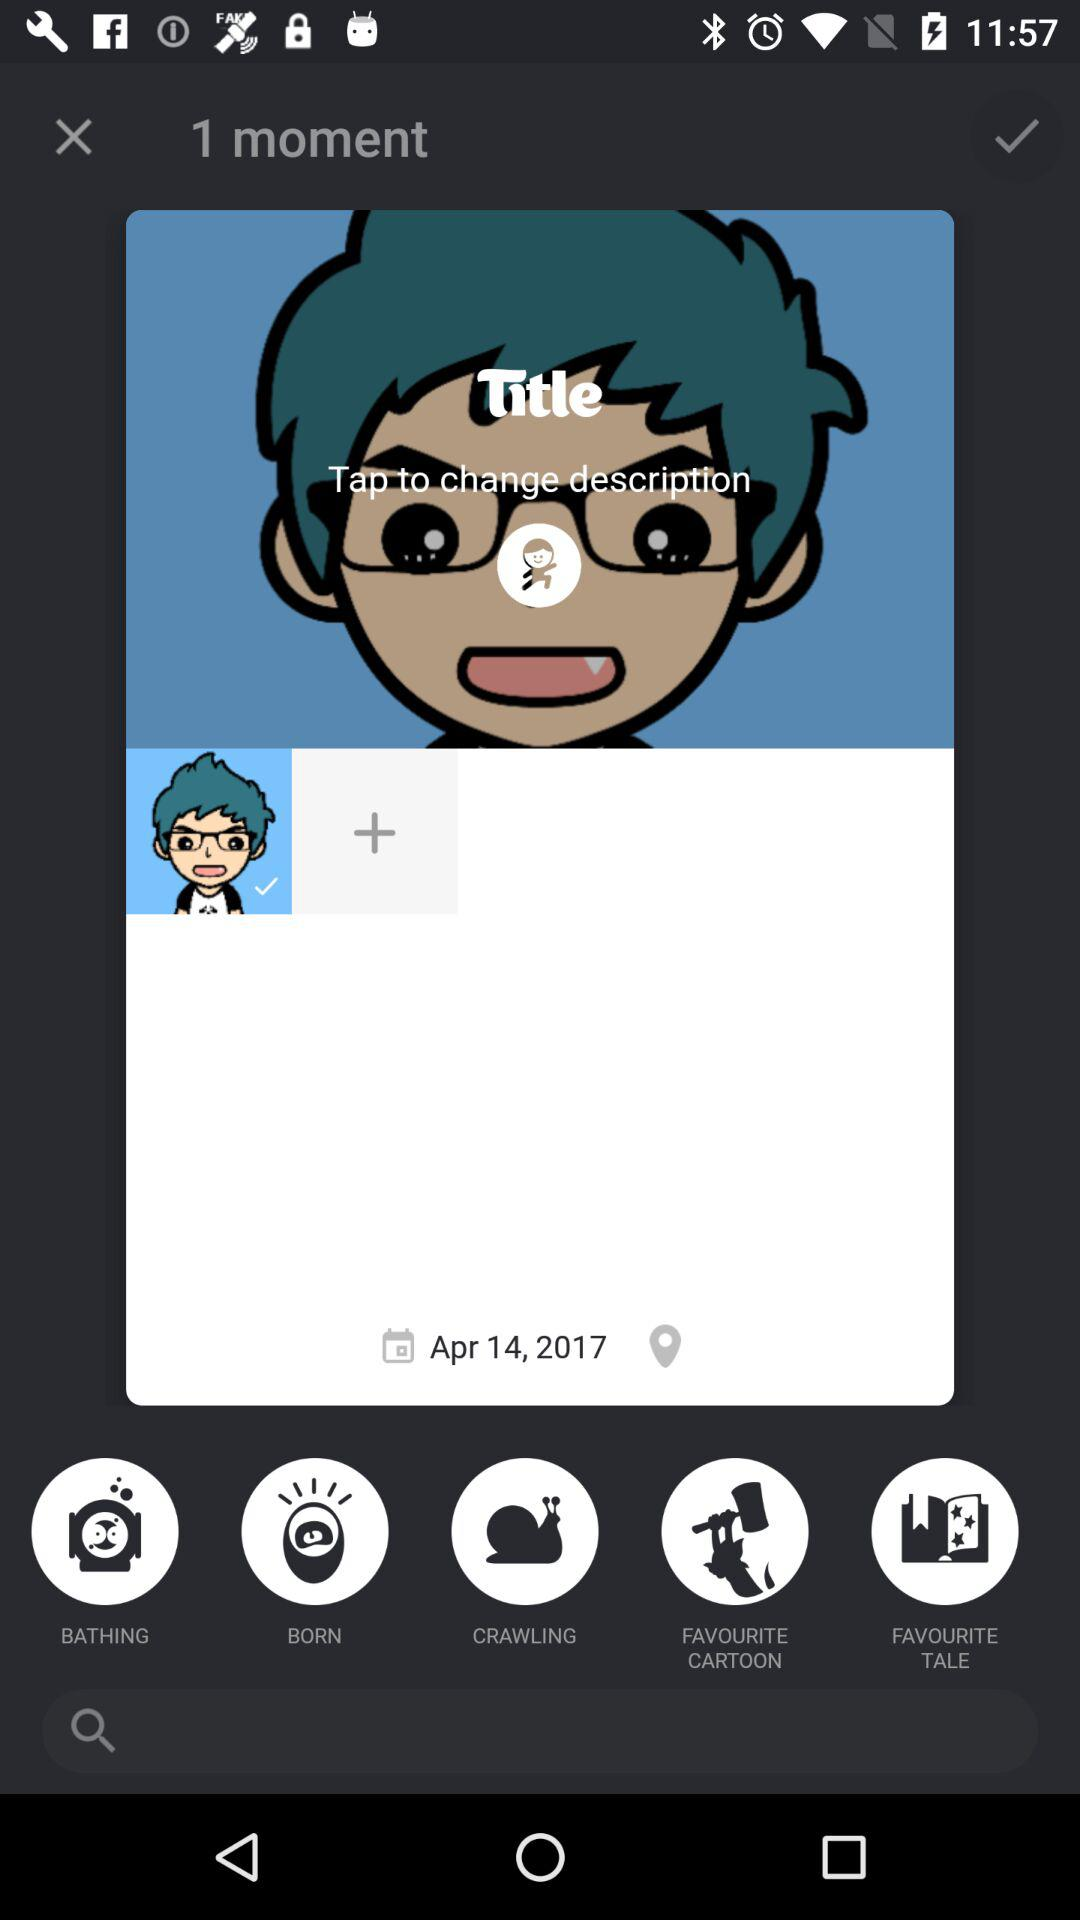What is the date of the moment?
Answer the question using a single word or phrase. Apr 14, 2017 